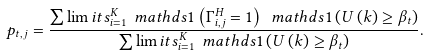Convert formula to latex. <formula><loc_0><loc_0><loc_500><loc_500>p _ { t , j } = \frac { \sum \lim i t s _ { i = 1 } ^ { K } \ m a t h d s { 1 } \left ( \Gamma ^ { H } _ { i , j } = 1 \right ) \ m a t h d s { 1 } \left ( U \left ( k \right ) \geq \beta _ { t } \right ) } { \sum \lim i t s _ { i = 1 } ^ { K } \ m a t h d s { 1 } \left ( U \left ( k \right ) \geq \beta _ { t } \right ) } .</formula> 